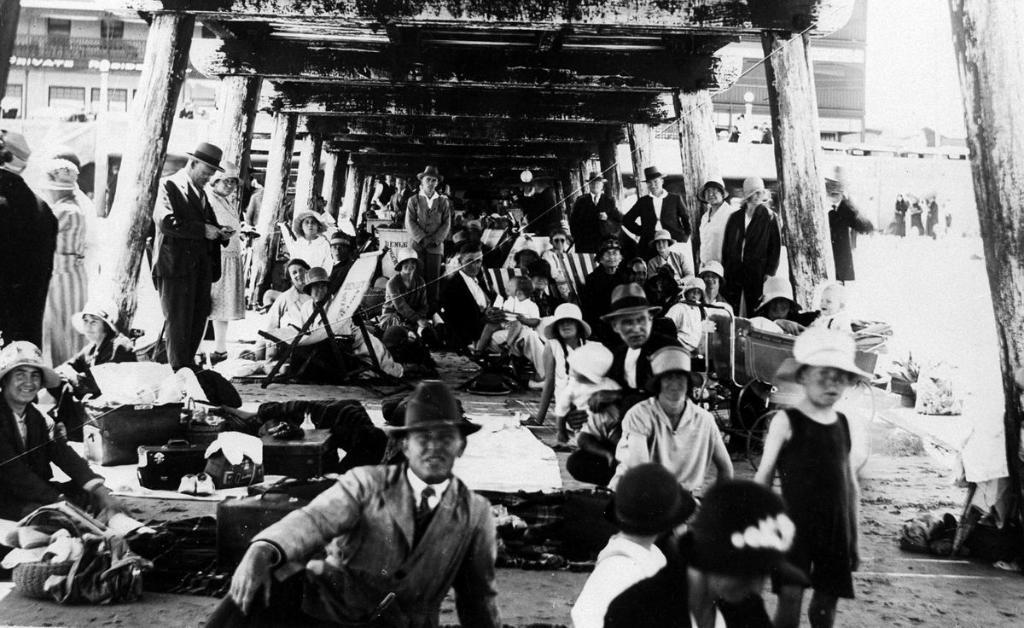What are the people at the bottom of the image doing? Some people are sitting, and some are standing at the bottom of the image. What can be seen above the people in the image? There is a roof at the top of the image. What is visible in the distance behind the people? There are buildings in the background of the image. What type of food is being ploughed in the image? There is no plough or food present in the image. Can you tell me who won the argument in the image? There is no argument present in the image. 